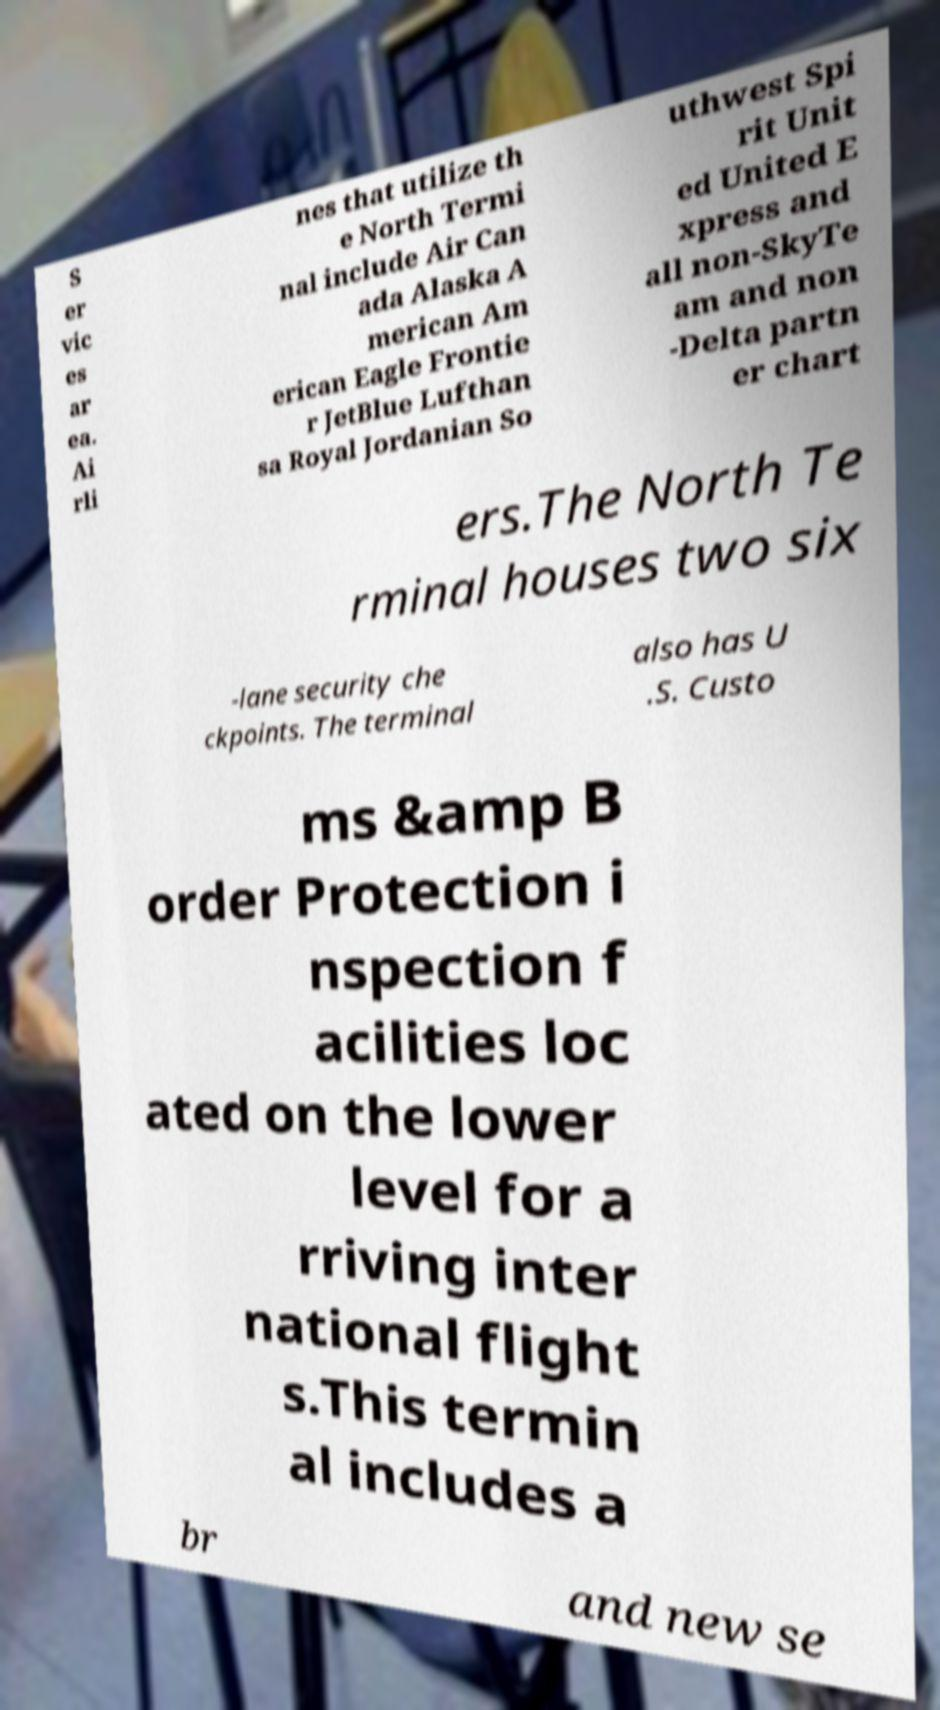Could you extract and type out the text from this image? S er vic es ar ea. Ai rli nes that utilize th e North Termi nal include Air Can ada Alaska A merican Am erican Eagle Frontie r JetBlue Lufthan sa Royal Jordanian So uthwest Spi rit Unit ed United E xpress and all non-SkyTe am and non -Delta partn er chart ers.The North Te rminal houses two six -lane security che ckpoints. The terminal also has U .S. Custo ms &amp B order Protection i nspection f acilities loc ated on the lower level for a rriving inter national flight s.This termin al includes a br and new se 